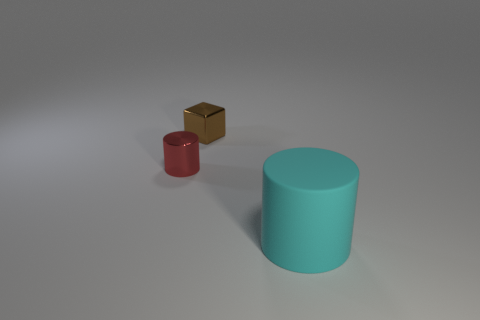Add 1 small red metallic cylinders. How many objects exist? 4 Subtract all cubes. How many objects are left? 2 Subtract 0 gray balls. How many objects are left? 3 Subtract all small gray metallic balls. Subtract all big matte cylinders. How many objects are left? 2 Add 2 small brown blocks. How many small brown blocks are left? 3 Add 3 large blue matte cylinders. How many large blue matte cylinders exist? 3 